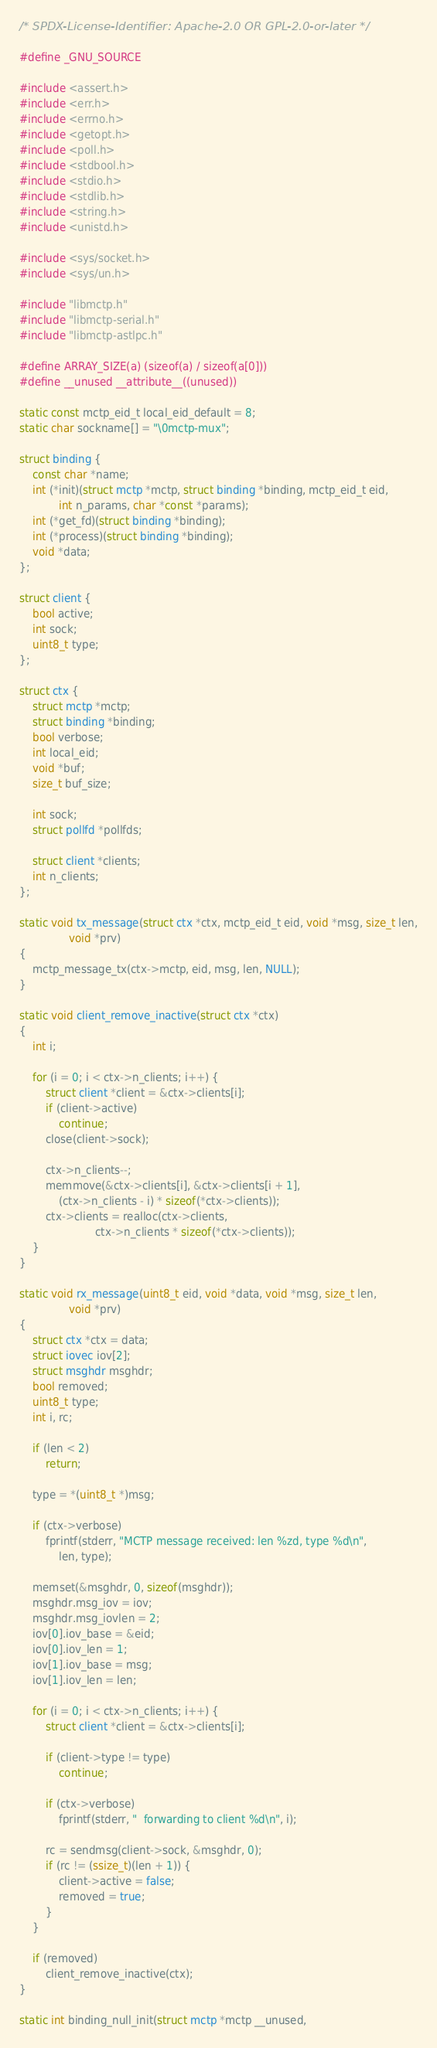<code> <loc_0><loc_0><loc_500><loc_500><_C_>/* SPDX-License-Identifier: Apache-2.0 OR GPL-2.0-or-later */

#define _GNU_SOURCE

#include <assert.h>
#include <err.h>
#include <errno.h>
#include <getopt.h>
#include <poll.h>
#include <stdbool.h>
#include <stdio.h>
#include <stdlib.h>
#include <string.h>
#include <unistd.h>

#include <sys/socket.h>
#include <sys/un.h>

#include "libmctp.h"
#include "libmctp-serial.h"
#include "libmctp-astlpc.h"

#define ARRAY_SIZE(a) (sizeof(a) / sizeof(a[0]))
#define __unused __attribute__((unused))

static const mctp_eid_t local_eid_default = 8;
static char sockname[] = "\0mctp-mux";

struct binding {
	const char *name;
	int (*init)(struct mctp *mctp, struct binding *binding, mctp_eid_t eid,
		    int n_params, char *const *params);
	int (*get_fd)(struct binding *binding);
	int (*process)(struct binding *binding);
	void *data;
};

struct client {
	bool active;
	int sock;
	uint8_t type;
};

struct ctx {
	struct mctp *mctp;
	struct binding *binding;
	bool verbose;
	int local_eid;
	void *buf;
	size_t buf_size;

	int sock;
	struct pollfd *pollfds;

	struct client *clients;
	int n_clients;
};

static void tx_message(struct ctx *ctx, mctp_eid_t eid, void *msg, size_t len,
		       void *prv)
{
	mctp_message_tx(ctx->mctp, eid, msg, len, NULL);
}

static void client_remove_inactive(struct ctx *ctx)
{
	int i;

	for (i = 0; i < ctx->n_clients; i++) {
		struct client *client = &ctx->clients[i];
		if (client->active)
			continue;
		close(client->sock);

		ctx->n_clients--;
		memmove(&ctx->clients[i], &ctx->clients[i + 1],
			(ctx->n_clients - i) * sizeof(*ctx->clients));
		ctx->clients = realloc(ctx->clients,
				       ctx->n_clients * sizeof(*ctx->clients));
	}
}

static void rx_message(uint8_t eid, void *data, void *msg, size_t len,
		       void *prv)
{
	struct ctx *ctx = data;
	struct iovec iov[2];
	struct msghdr msghdr;
	bool removed;
	uint8_t type;
	int i, rc;

	if (len < 2)
		return;

	type = *(uint8_t *)msg;

	if (ctx->verbose)
		fprintf(stderr, "MCTP message received: len %zd, type %d\n",
			len, type);

	memset(&msghdr, 0, sizeof(msghdr));
	msghdr.msg_iov = iov;
	msghdr.msg_iovlen = 2;
	iov[0].iov_base = &eid;
	iov[0].iov_len = 1;
	iov[1].iov_base = msg;
	iov[1].iov_len = len;

	for (i = 0; i < ctx->n_clients; i++) {
		struct client *client = &ctx->clients[i];

		if (client->type != type)
			continue;

		if (ctx->verbose)
			fprintf(stderr, "  forwarding to client %d\n", i);

		rc = sendmsg(client->sock, &msghdr, 0);
		if (rc != (ssize_t)(len + 1)) {
			client->active = false;
			removed = true;
		}
	}

	if (removed)
		client_remove_inactive(ctx);
}

static int binding_null_init(struct mctp *mctp __unused,</code> 